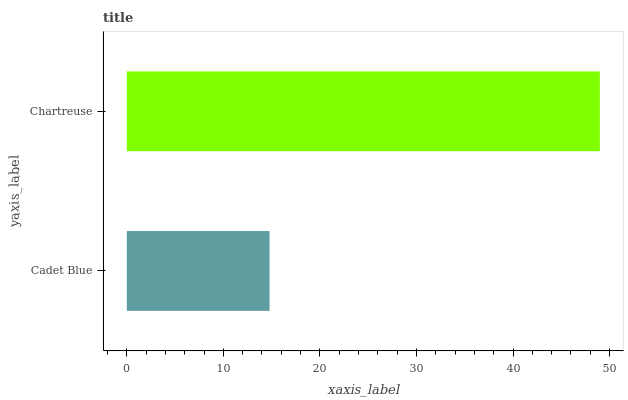Is Cadet Blue the minimum?
Answer yes or no. Yes. Is Chartreuse the maximum?
Answer yes or no. Yes. Is Chartreuse the minimum?
Answer yes or no. No. Is Chartreuse greater than Cadet Blue?
Answer yes or no. Yes. Is Cadet Blue less than Chartreuse?
Answer yes or no. Yes. Is Cadet Blue greater than Chartreuse?
Answer yes or no. No. Is Chartreuse less than Cadet Blue?
Answer yes or no. No. Is Chartreuse the high median?
Answer yes or no. Yes. Is Cadet Blue the low median?
Answer yes or no. Yes. Is Cadet Blue the high median?
Answer yes or no. No. Is Chartreuse the low median?
Answer yes or no. No. 